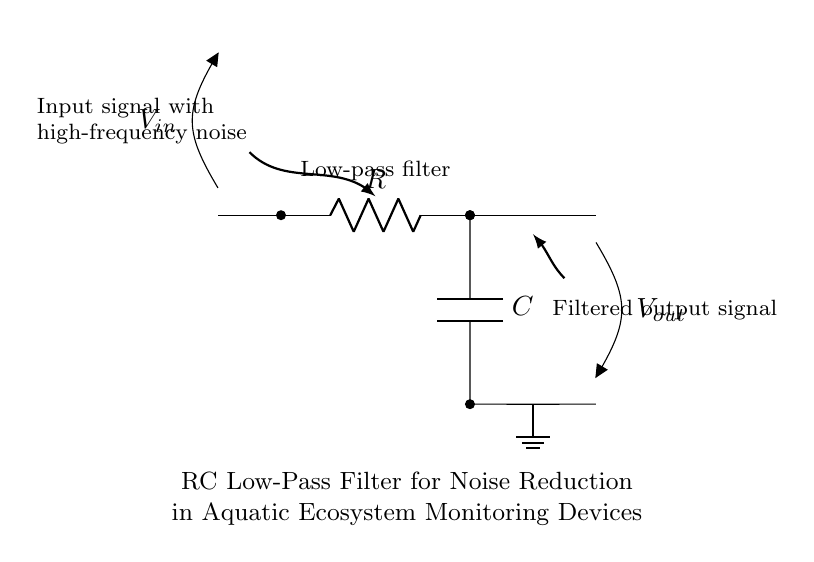What is the input signal? The input signal is indicated as V_in, which represents the voltage entering the circuit from the source, often contaminated with high-frequency noise.
Answer: V_in What components are present in this circuit? The circuit consists of a resistor and a capacitor, as shown by their respective symbols R and C in the diagram.
Answer: Resistor and Capacitor What is the function of this circuit? The circuit is classified as a low-pass filter, which allows low-frequency signals to pass while attenuating (reducing) high-frequency noise.
Answer: Low-pass filter What does the output signal represent? The output signal, denoted as V_out, is the voltage that has passed through the filter, representing the cleaned or filtered version of the input signal.
Answer: V_out What happens to high-frequency noise in this circuit? The high-frequency noise is attenuated by the low-pass filter, preventing it from appearing in the output signal while allowing the desired low-frequency signals to pass through.
Answer: Attenuated What is the relationship between the resistor and capacitor in this filter? The resistor and capacitor are connected in series, and they form a time constant that determines the cut-off frequency of the filter, affecting how quickly the circuit responds to changes in the input signal.
Answer: Series connection What is the significance of the ground in this circuit? The ground connection serves as a reference point for the circuit, ensuring stable measurements of voltages like V_out and providing a return path for current.
Answer: Reference point 